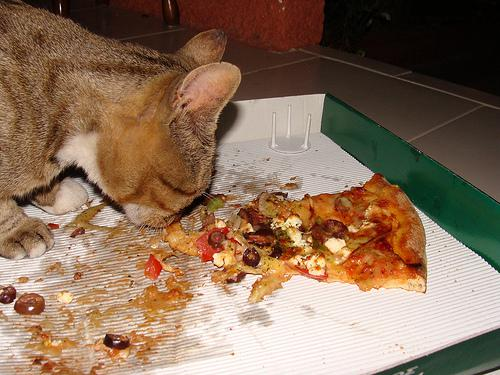Question: what is the cat doing?
Choices:
A. Eating a cake.
B. Eating a sandwich.
C. Eating a pie.
D. Eating a pizza slice.
Answer with the letter. Answer: D Question: why is the cat there?
Choices:
A. To drink.
B. To eat.
C. To sleep.
D. To play.
Answer with the letter. Answer: B 